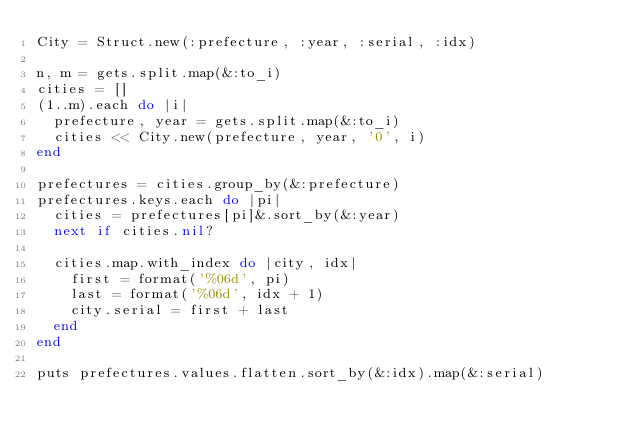<code> <loc_0><loc_0><loc_500><loc_500><_Ruby_>City = Struct.new(:prefecture, :year, :serial, :idx)

n, m = gets.split.map(&:to_i)
cities = []
(1..m).each do |i|
  prefecture, year = gets.split.map(&:to_i)
  cities << City.new(prefecture, year, '0', i)
end

prefectures = cities.group_by(&:prefecture)
prefectures.keys.each do |pi|
  cities = prefectures[pi]&.sort_by(&:year)
  next if cities.nil?

  cities.map.with_index do |city, idx|
    first = format('%06d', pi)
    last = format('%06d', idx + 1)
    city.serial = first + last
  end
end

puts prefectures.values.flatten.sort_by(&:idx).map(&:serial)
</code> 